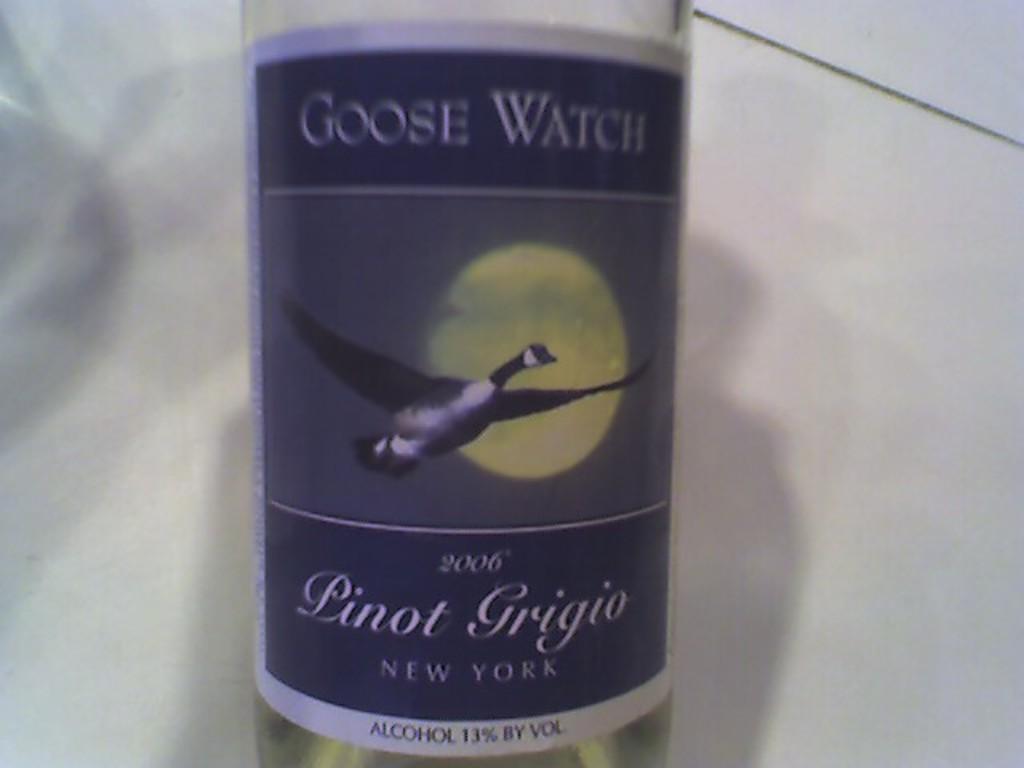In one or two sentences, can you explain what this image depicts? In this image, we can see an alcohol bottle. 